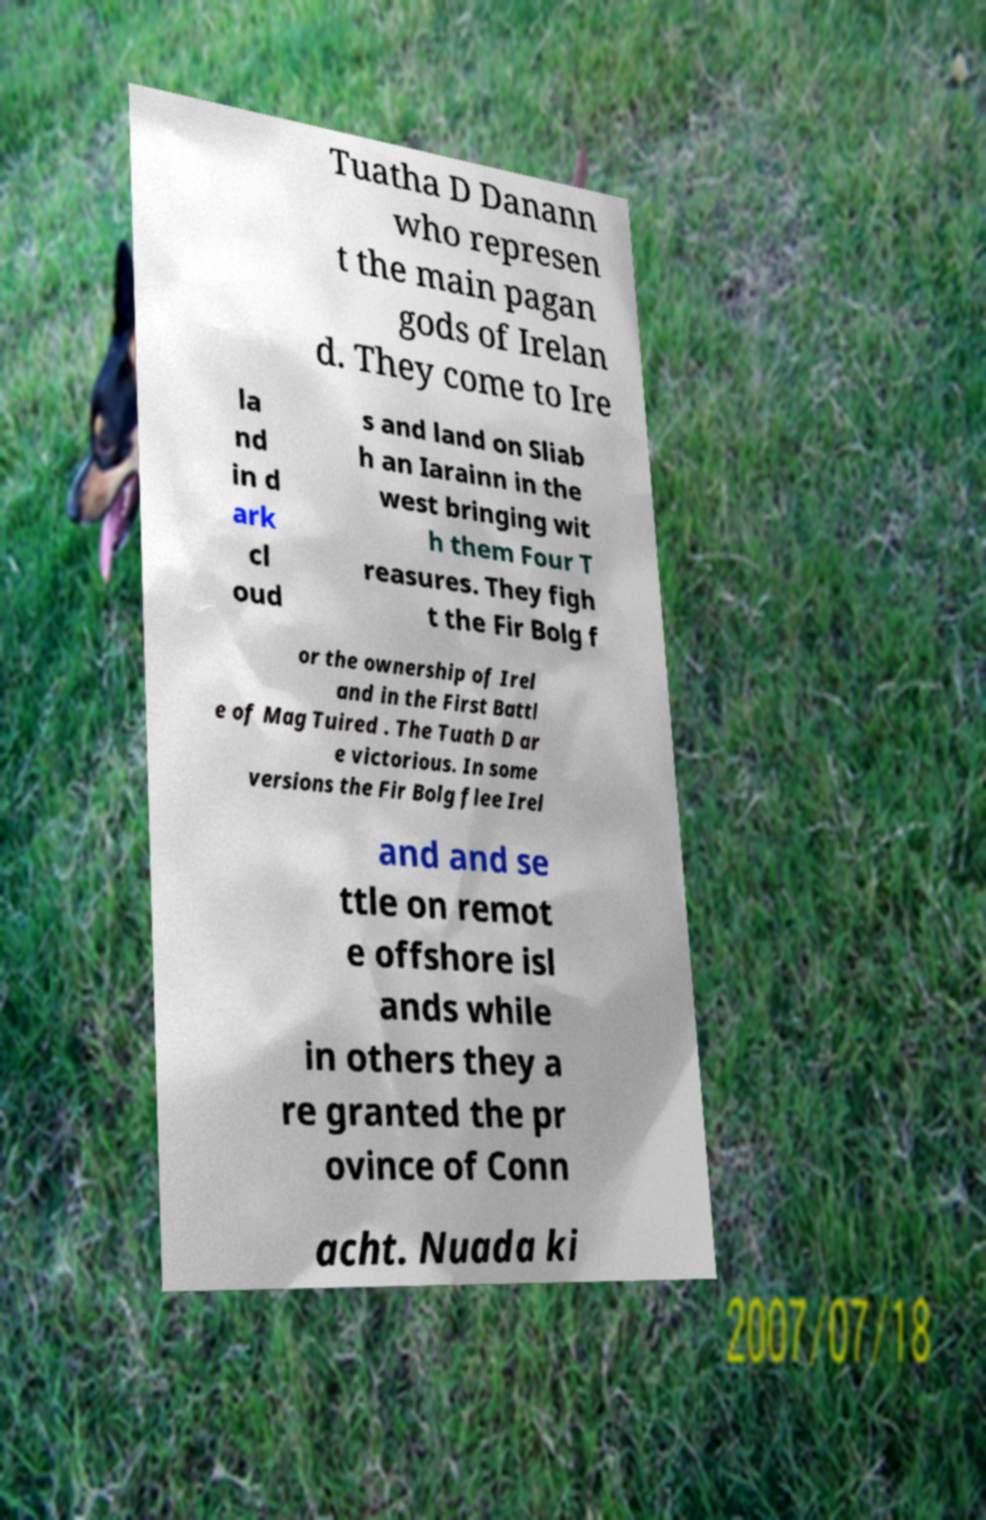Could you assist in decoding the text presented in this image and type it out clearly? Tuatha D Danann who represen t the main pagan gods of Irelan d. They come to Ire la nd in d ark cl oud s and land on Sliab h an Iarainn in the west bringing wit h them Four T reasures. They figh t the Fir Bolg f or the ownership of Irel and in the First Battl e of Mag Tuired . The Tuath D ar e victorious. In some versions the Fir Bolg flee Irel and and se ttle on remot e offshore isl ands while in others they a re granted the pr ovince of Conn acht. Nuada ki 